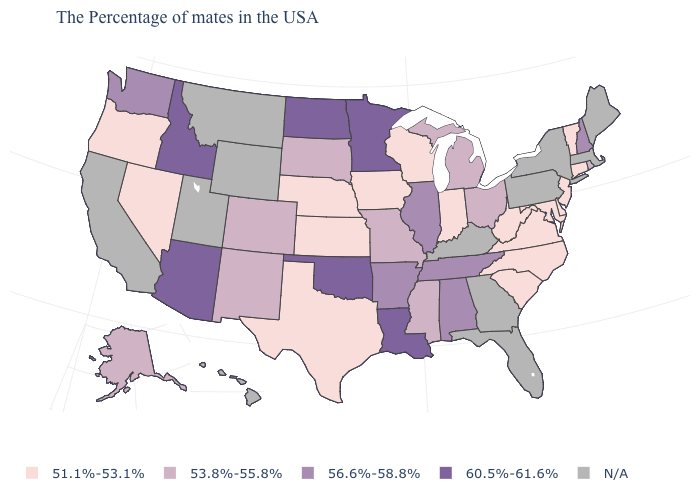Does Texas have the highest value in the USA?
Write a very short answer. No. What is the value of California?
Keep it brief. N/A. How many symbols are there in the legend?
Write a very short answer. 5. What is the value of Wyoming?
Concise answer only. N/A. Which states have the lowest value in the South?
Give a very brief answer. Delaware, Maryland, Virginia, North Carolina, South Carolina, West Virginia, Texas. What is the value of Kansas?
Answer briefly. 51.1%-53.1%. Among the states that border West Virginia , which have the highest value?
Keep it brief. Ohio. Which states have the lowest value in the MidWest?
Concise answer only. Indiana, Wisconsin, Iowa, Kansas, Nebraska. Among the states that border Louisiana , does Texas have the lowest value?
Be succinct. Yes. Does the first symbol in the legend represent the smallest category?
Give a very brief answer. Yes. What is the highest value in the Northeast ?
Quick response, please. 56.6%-58.8%. Is the legend a continuous bar?
Answer briefly. No. Which states have the highest value in the USA?
Answer briefly. Louisiana, Minnesota, Oklahoma, North Dakota, Arizona, Idaho. What is the highest value in the MidWest ?
Give a very brief answer. 60.5%-61.6%. 